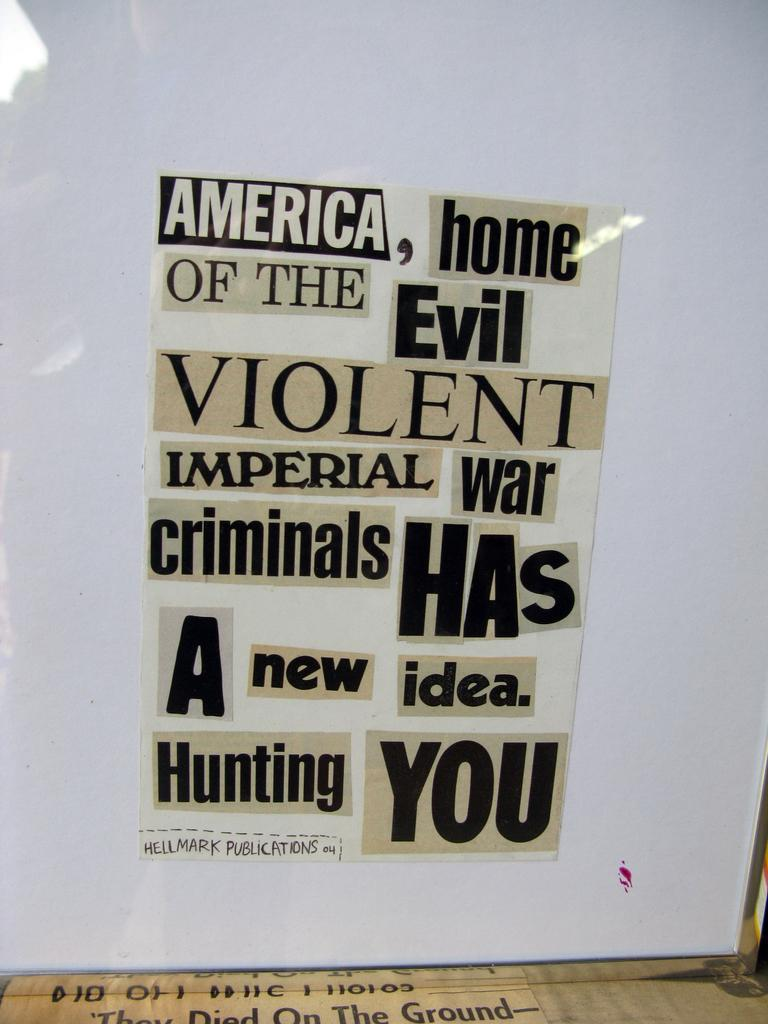<image>
Give a short and clear explanation of the subsequent image. A paper with cut out words the last two of which are Hunting you 